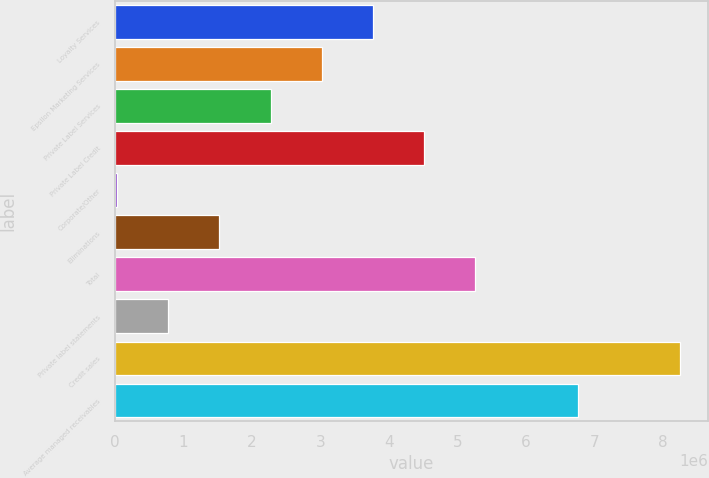<chart> <loc_0><loc_0><loc_500><loc_500><bar_chart><fcel>Loyalty Services<fcel>Epsilon Marketing Services<fcel>Private Label Services<fcel>Private Label Credit<fcel>Corporate/Other<fcel>Eliminations<fcel>Total<fcel>Private label statements<fcel>Credit sales<fcel>Average managed receivables<nl><fcel>3.76815e+06<fcel>3.02119e+06<fcel>2.27424e+06<fcel>4.51511e+06<fcel>33360<fcel>1.52728e+06<fcel>5.26207e+06<fcel>780319<fcel>8.24991e+06<fcel>6.75599e+06<nl></chart> 